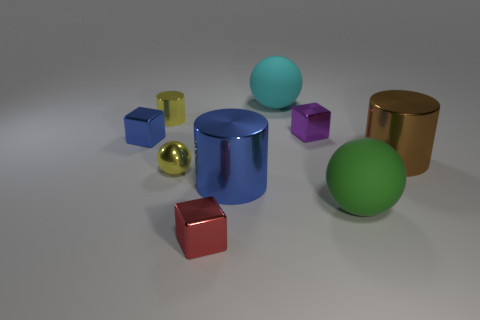Subtract 1 spheres. How many spheres are left? 2 Subtract all shiny balls. How many balls are left? 2 Add 1 red rubber balls. How many objects exist? 10 Subtract all cubes. How many objects are left? 6 Add 4 red things. How many red things exist? 5 Subtract 1 yellow balls. How many objects are left? 8 Subtract all small purple blocks. Subtract all tiny metal cylinders. How many objects are left? 7 Add 2 big objects. How many big objects are left? 6 